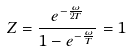Convert formula to latex. <formula><loc_0><loc_0><loc_500><loc_500>Z = \frac { e ^ { - \frac { \omega } { 2 T } } } { 1 - e ^ { - \frac { \omega } { T } } } = 1</formula> 